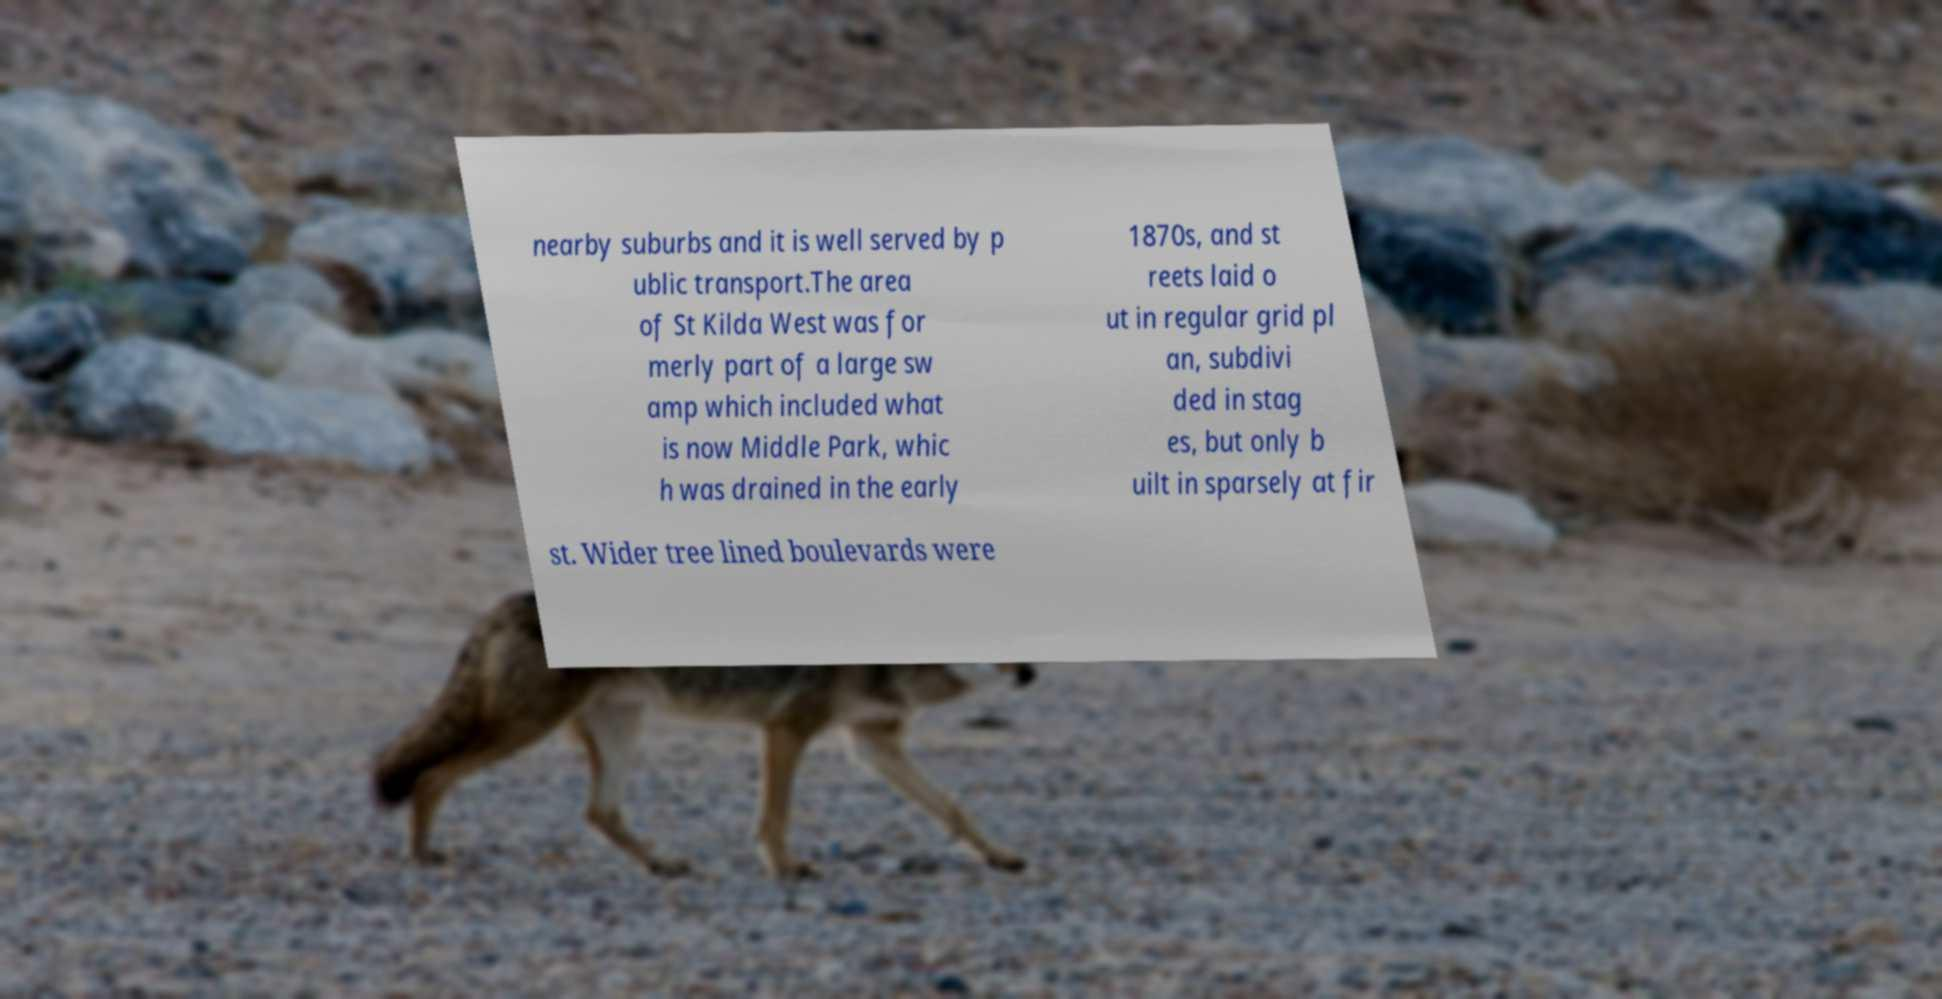There's text embedded in this image that I need extracted. Can you transcribe it verbatim? nearby suburbs and it is well served by p ublic transport.The area of St Kilda West was for merly part of a large sw amp which included what is now Middle Park, whic h was drained in the early 1870s, and st reets laid o ut in regular grid pl an, subdivi ded in stag es, but only b uilt in sparsely at fir st. Wider tree lined boulevards were 